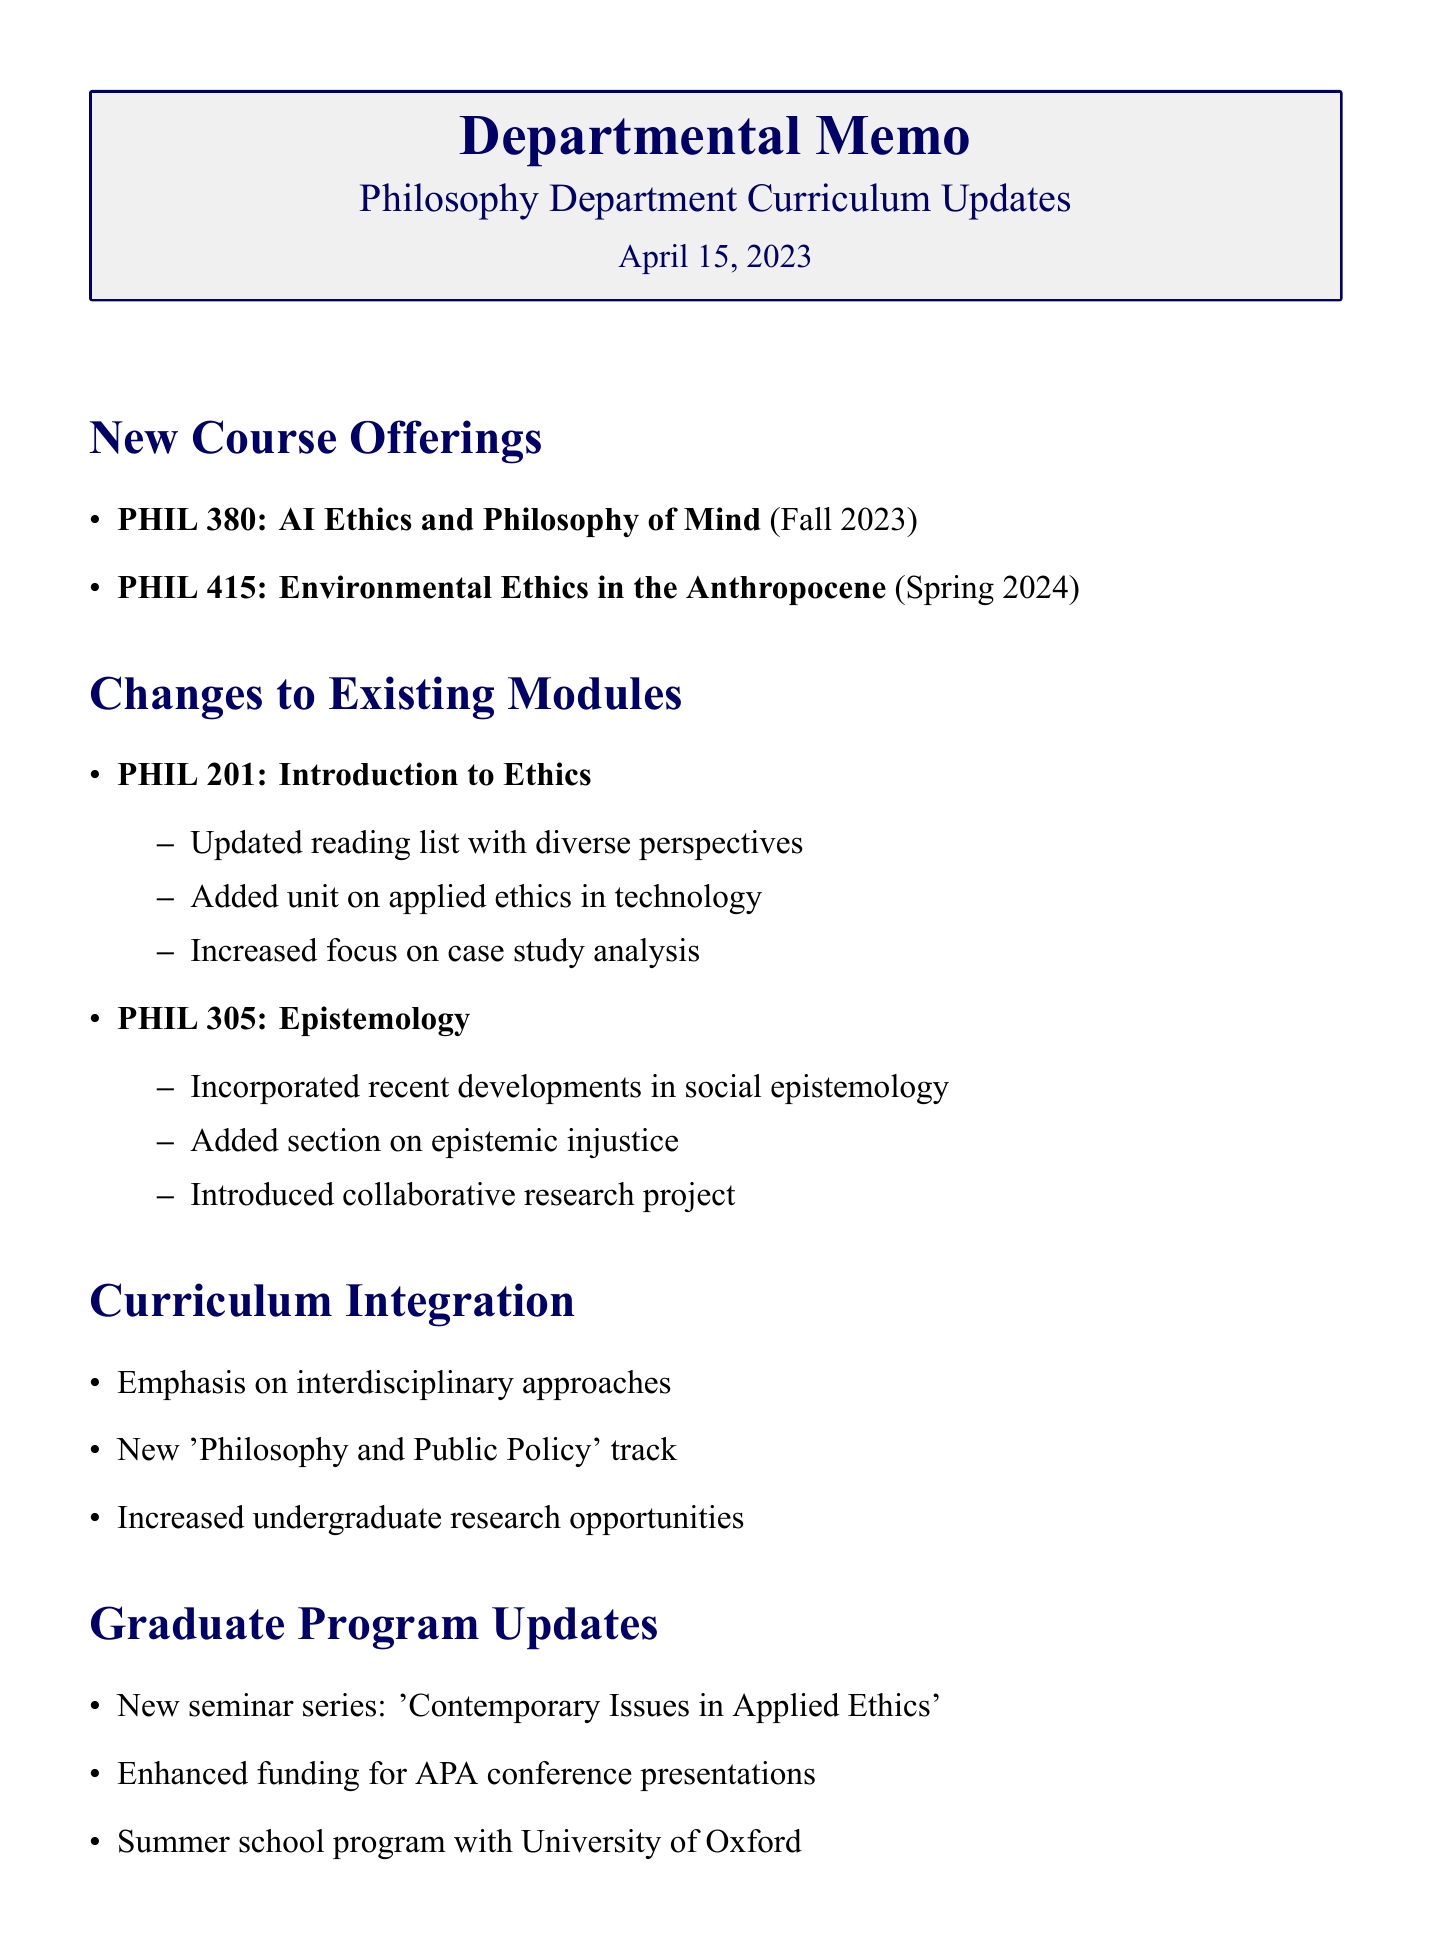What is the date of the meeting? The meeting is dated April 15, 2023.
Answer: April 15, 2023 Who is the instructor for PHIL 380? Dr. Sarah Williams is listed as the instructor for PHIL 380.
Answer: Dr. Sarah Williams What are the changes made to PHIL 201? The changes include an updated reading list, a unit on applied ethics in technology, and an increased focus on case study analysis.
Answer: Updated reading list, added unit on applied ethics in technology, increased focus on case study analysis Which department is coordinating for cross-listed courses? Dr. Michael Johnson is tasked with coordinating with Environmental Studies.
Answer: Environmental Studies What is the deadline for finalizing the syllabus for PHIL 380? The deadline to finalize the syllabus for PHIL 380 is May 31, 2023.
Answer: May 31, 2023 How many new course offerings were discussed in the meeting? Two new course offerings were mentioned: PHIL 380 and PHIL 415.
Answer: Two What is the new track introduced in the curriculum? The new track introduced is 'Philosophy and Public Policy'.
Answer: Philosophy and Public Policy When is the next departmental meeting scheduled? The next meeting is scheduled for May 20, 2023.
Answer: May 20, 2023 What type of seminar series is being introduced for the graduate program? A seminar series on 'Contemporary Issues in Applied Ethics' is being introduced.
Answer: Contemporary Issues in Applied Ethics 